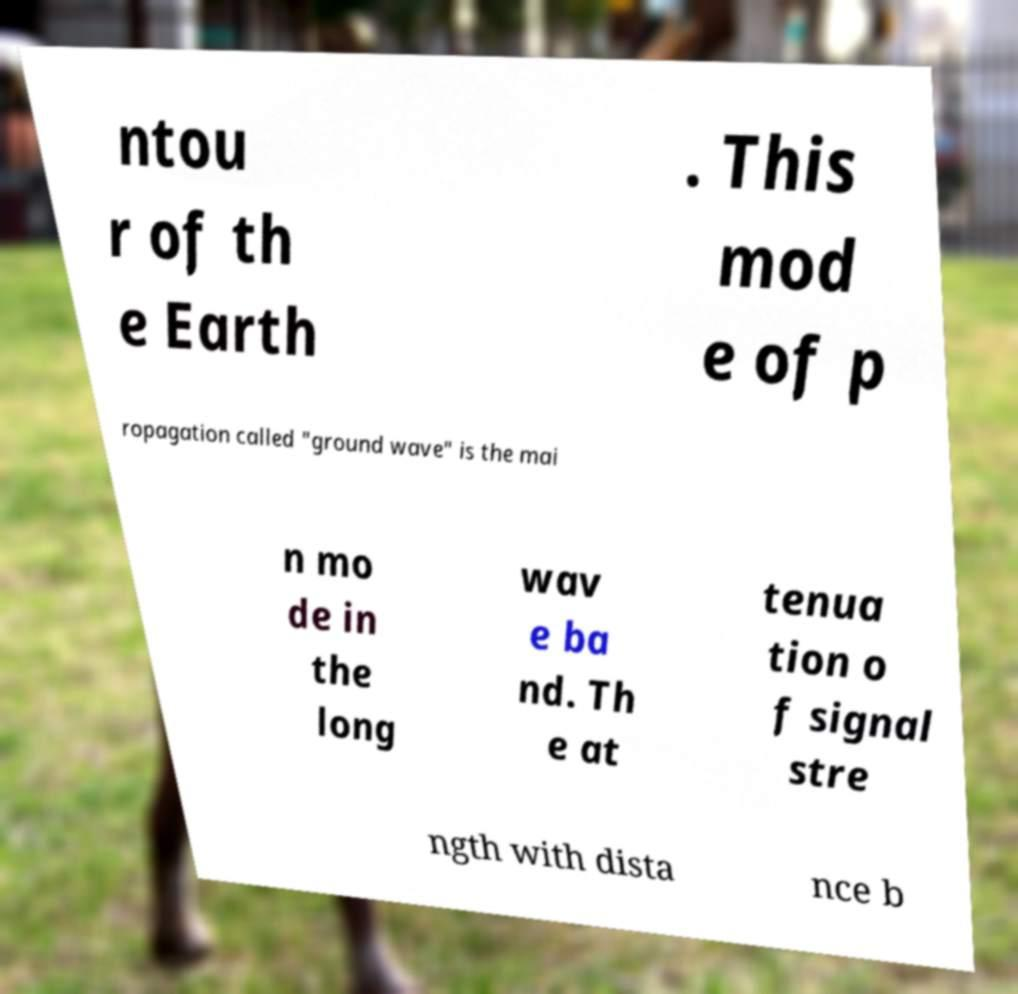For documentation purposes, I need the text within this image transcribed. Could you provide that? ntou r of th e Earth . This mod e of p ropagation called "ground wave" is the mai n mo de in the long wav e ba nd. Th e at tenua tion o f signal stre ngth with dista nce b 